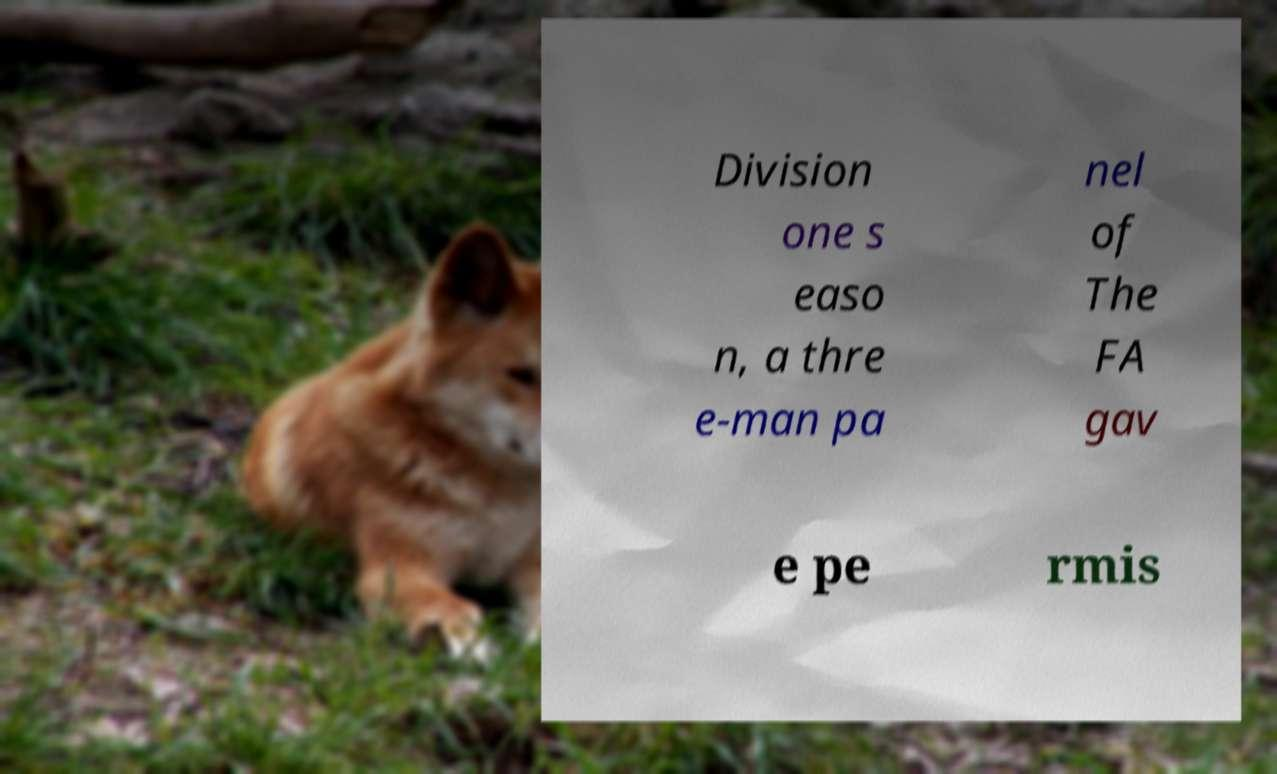For documentation purposes, I need the text within this image transcribed. Could you provide that? Division one s easo n, a thre e-man pa nel of The FA gav e pe rmis 